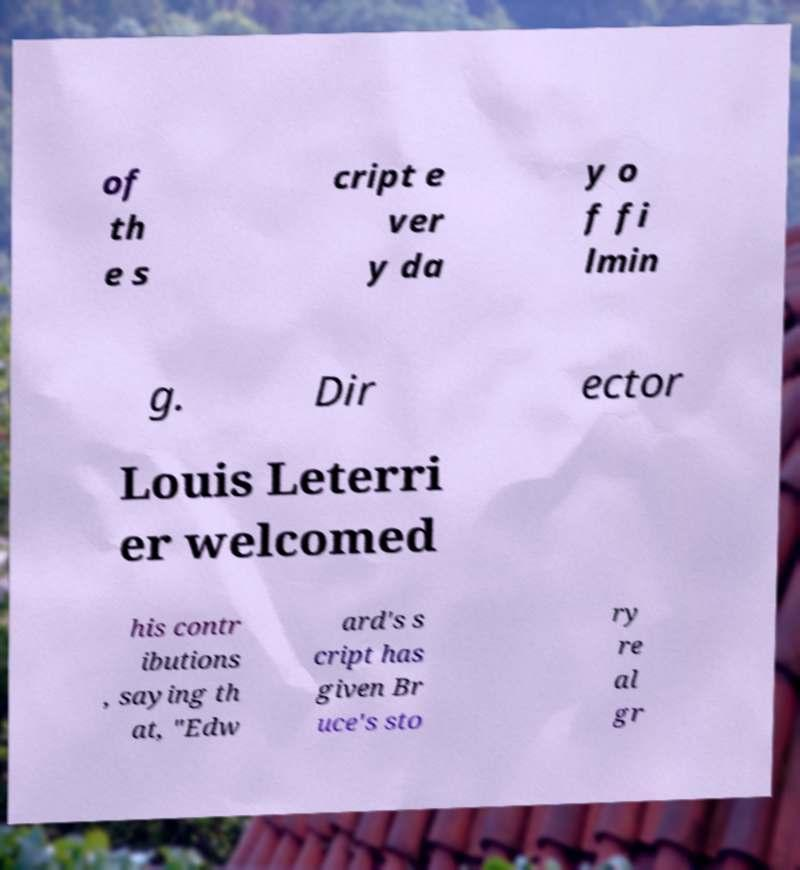Please identify and transcribe the text found in this image. of th e s cript e ver y da y o f fi lmin g. Dir ector Louis Leterri er welcomed his contr ibutions , saying th at, "Edw ard's s cript has given Br uce's sto ry re al gr 